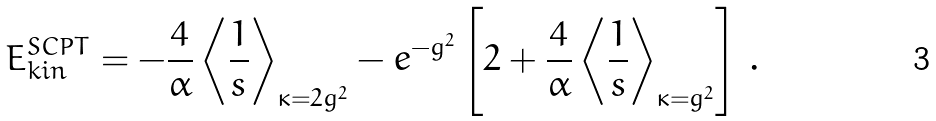Convert formula to latex. <formula><loc_0><loc_0><loc_500><loc_500>E _ { k i n } ^ { S C P T } = - \frac { 4 } { \alpha } \left \langle \frac { 1 } { s } \right \rangle _ { \kappa = 2 g ^ { 2 } } - e ^ { - g ^ { 2 } } \left [ 2 + \frac { 4 } { \alpha } \left \langle \frac { 1 } { s } \right \rangle _ { \kappa = g ^ { 2 } } \right ] \, .</formula> 